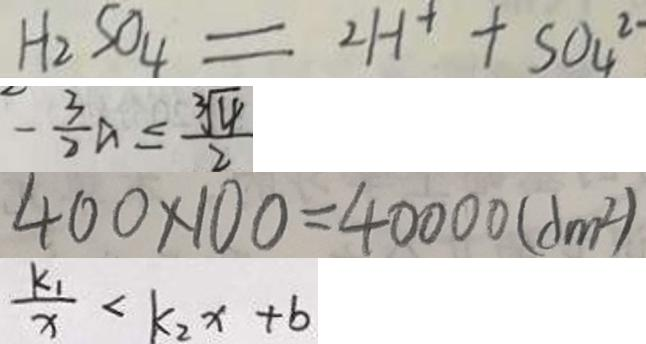Convert formula to latex. <formula><loc_0><loc_0><loc_500><loc_500>H _ { 2 } S O _ { 4 } = 2 H ^ { + } + S O _ { 4 } ^ { 2 - } 
 - \frac { 3 } { 2 } a \leq \frac { \sqrt [ 3 ] { 4 } } { 2 } 
 4 0 0 \times 1 0 0 = 4 0 0 0 0 ( d m ^ { 2 } ) 
 \frac { k _ { 1 } } { x } < k _ { 2 } x + b</formula> 